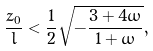<formula> <loc_0><loc_0><loc_500><loc_500>\frac { z _ { 0 } } { l } < \frac { 1 } { 2 } \sqrt { - \frac { 3 + 4 \omega } { 1 + \omega } } ,</formula> 